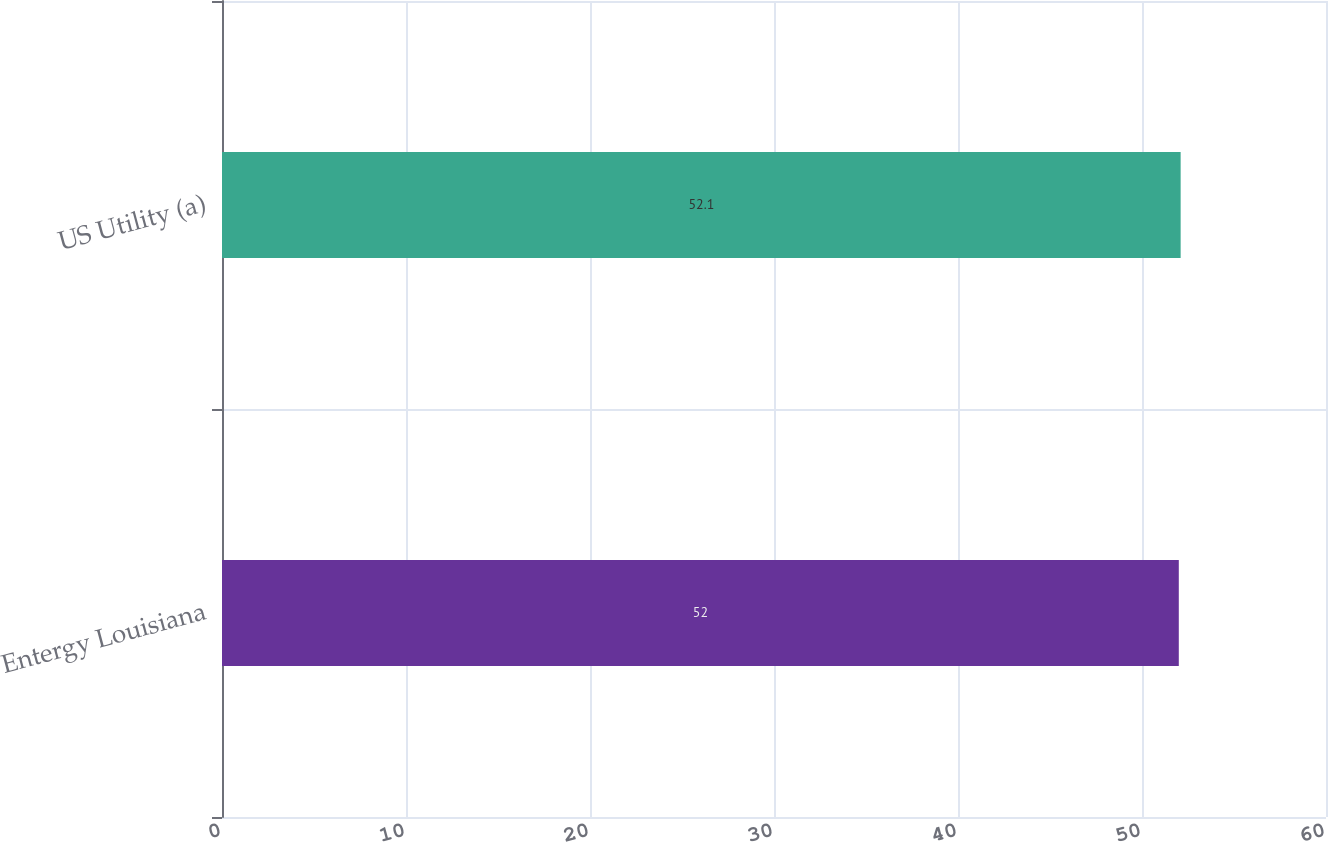Convert chart. <chart><loc_0><loc_0><loc_500><loc_500><bar_chart><fcel>Entergy Louisiana<fcel>US Utility (a)<nl><fcel>52<fcel>52.1<nl></chart> 